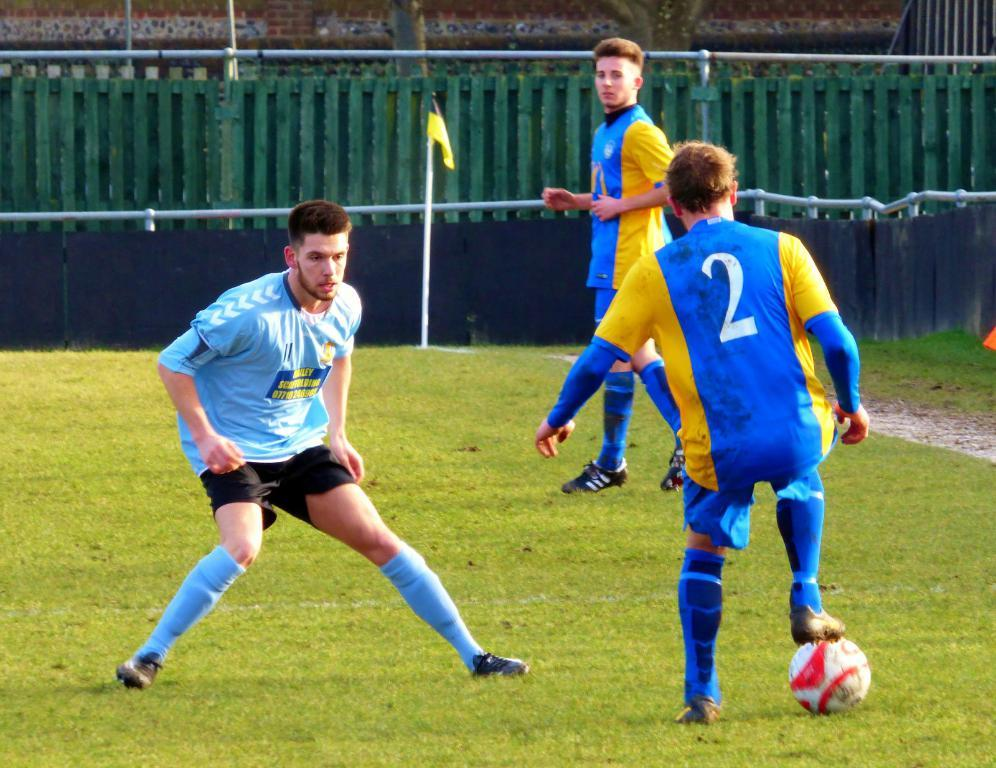<image>
Present a compact description of the photo's key features. Player number 2 has the ball, and another player moves in front of him. 